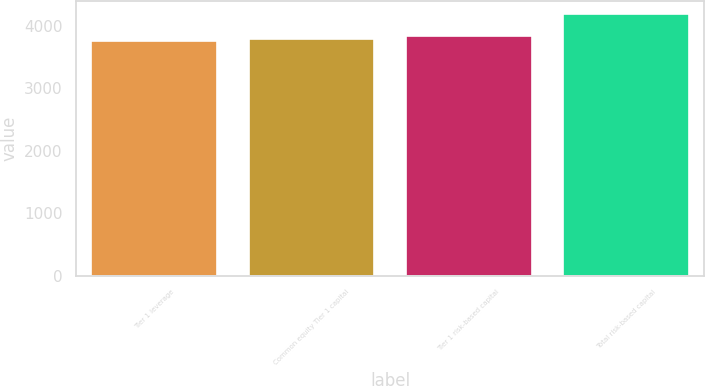Convert chart. <chart><loc_0><loc_0><loc_500><loc_500><bar_chart><fcel>Tier 1 leverage<fcel>Common equity Tier 1 capital<fcel>Tier 1 risk-based capital<fcel>Total risk-based capital<nl><fcel>3747<fcel>3790.9<fcel>3834.8<fcel>4186<nl></chart> 